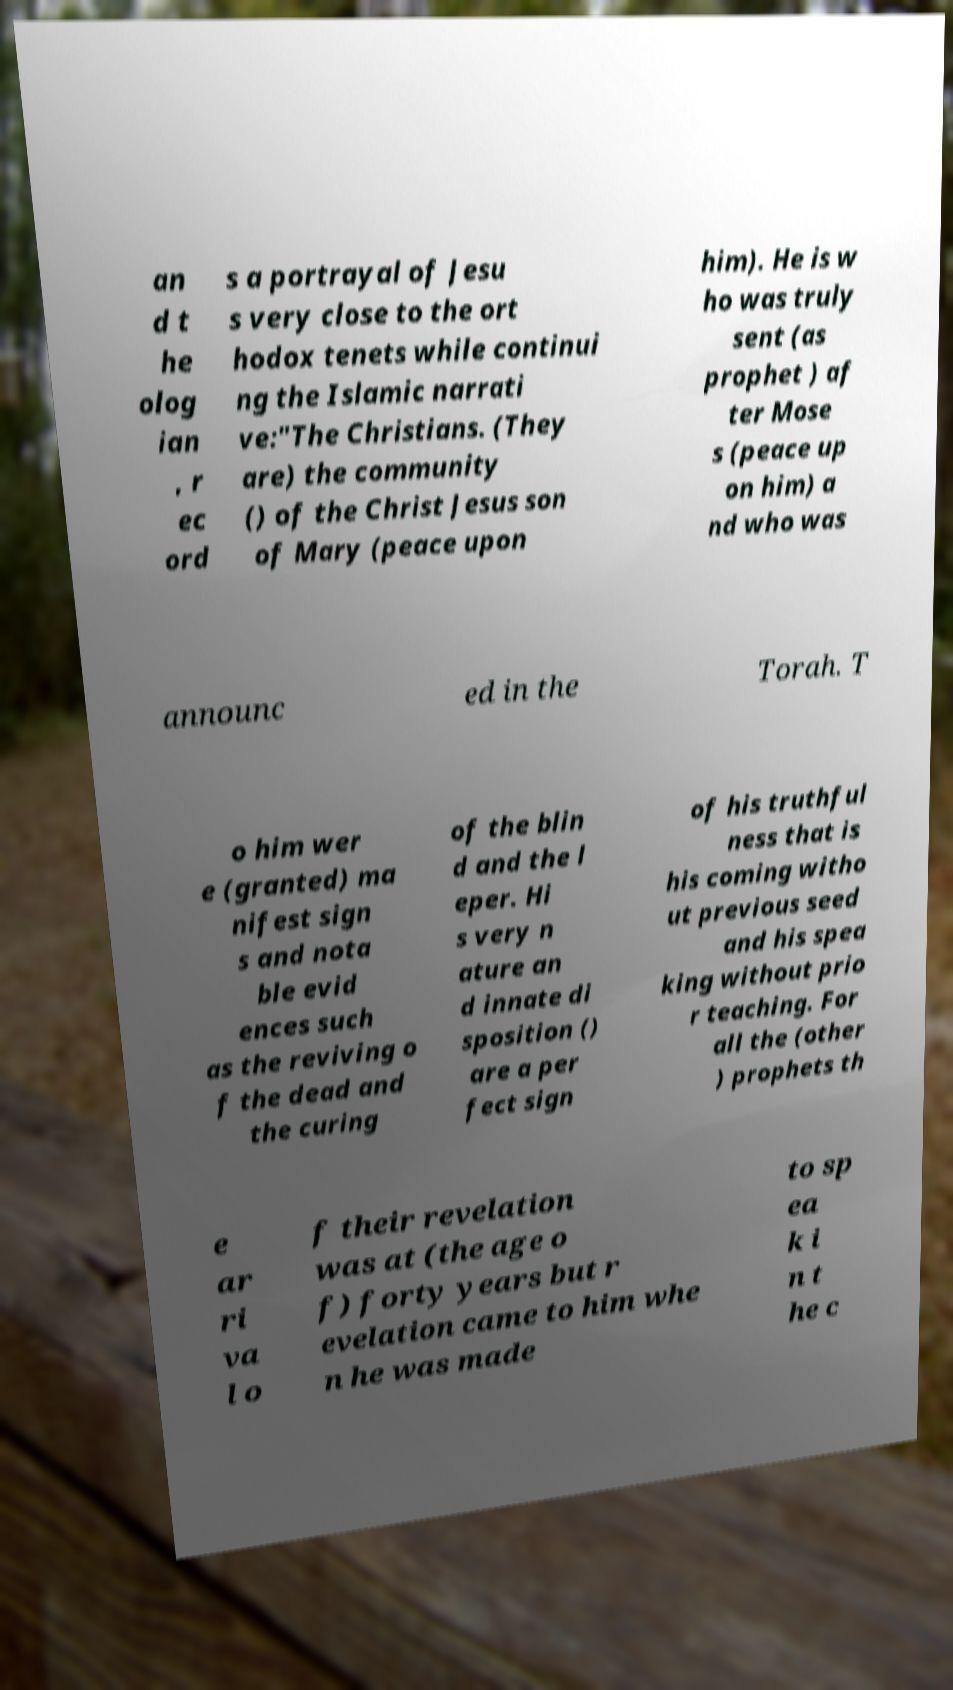Can you accurately transcribe the text from the provided image for me? an d t he olog ian , r ec ord s a portrayal of Jesu s very close to the ort hodox tenets while continui ng the Islamic narrati ve:"The Christians. (They are) the community () of the Christ Jesus son of Mary (peace upon him). He is w ho was truly sent (as prophet ) af ter Mose s (peace up on him) a nd who was announc ed in the Torah. T o him wer e (granted) ma nifest sign s and nota ble evid ences such as the reviving o f the dead and the curing of the blin d and the l eper. Hi s very n ature an d innate di sposition () are a per fect sign of his truthful ness that is his coming witho ut previous seed and his spea king without prio r teaching. For all the (other ) prophets th e ar ri va l o f their revelation was at (the age o f) forty years but r evelation came to him whe n he was made to sp ea k i n t he c 